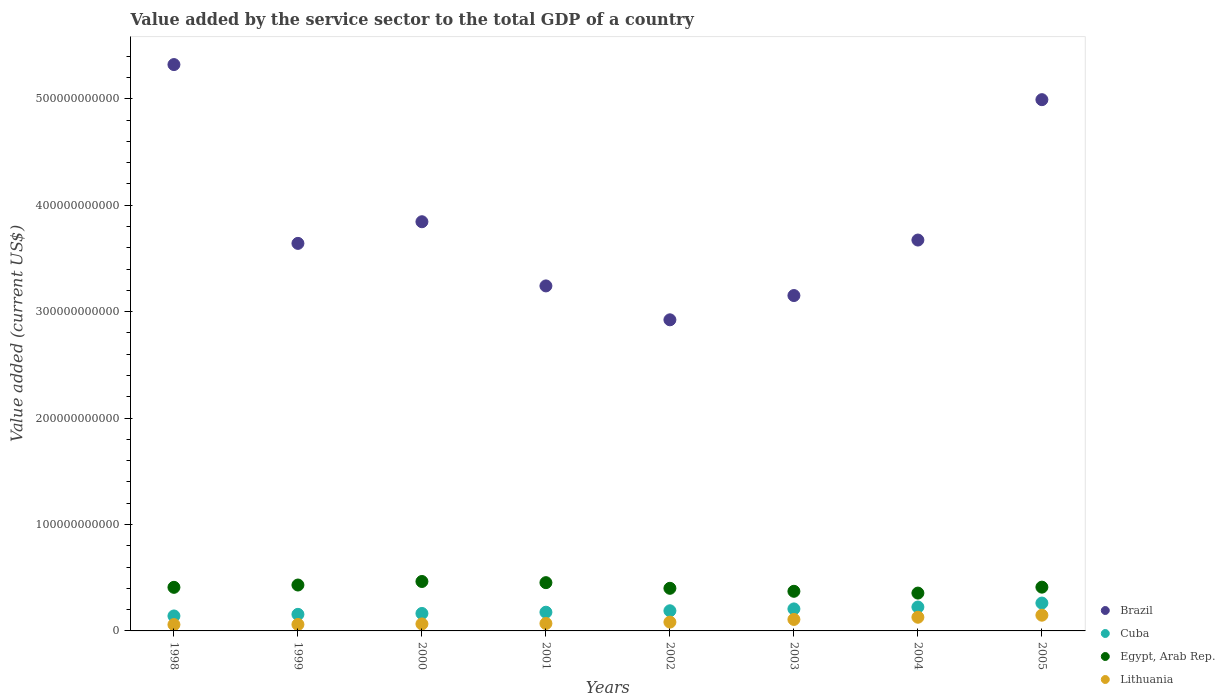Is the number of dotlines equal to the number of legend labels?
Your answer should be compact. Yes. What is the value added by the service sector to the total GDP in Lithuania in 2001?
Make the answer very short. 7.00e+09. Across all years, what is the maximum value added by the service sector to the total GDP in Brazil?
Offer a terse response. 5.32e+11. Across all years, what is the minimum value added by the service sector to the total GDP in Egypt, Arab Rep.?
Make the answer very short. 3.56e+1. In which year was the value added by the service sector to the total GDP in Lithuania maximum?
Your answer should be compact. 2005. In which year was the value added by the service sector to the total GDP in Lithuania minimum?
Keep it short and to the point. 1998. What is the total value added by the service sector to the total GDP in Brazil in the graph?
Keep it short and to the point. 3.08e+12. What is the difference between the value added by the service sector to the total GDP in Lithuania in 2000 and that in 2004?
Provide a short and direct response. -6.28e+09. What is the difference between the value added by the service sector to the total GDP in Egypt, Arab Rep. in 1998 and the value added by the service sector to the total GDP in Cuba in 2004?
Ensure brevity in your answer.  1.85e+1. What is the average value added by the service sector to the total GDP in Cuba per year?
Your answer should be compact. 1.90e+1. In the year 2001, what is the difference between the value added by the service sector to the total GDP in Egypt, Arab Rep. and value added by the service sector to the total GDP in Cuba?
Provide a short and direct response. 2.78e+1. What is the ratio of the value added by the service sector to the total GDP in Lithuania in 1999 to that in 2000?
Make the answer very short. 0.92. What is the difference between the highest and the second highest value added by the service sector to the total GDP in Lithuania?
Make the answer very short. 1.93e+09. What is the difference between the highest and the lowest value added by the service sector to the total GDP in Brazil?
Make the answer very short. 2.40e+11. In how many years, is the value added by the service sector to the total GDP in Lithuania greater than the average value added by the service sector to the total GDP in Lithuania taken over all years?
Make the answer very short. 3. Is the sum of the value added by the service sector to the total GDP in Cuba in 1998 and 1999 greater than the maximum value added by the service sector to the total GDP in Egypt, Arab Rep. across all years?
Your answer should be compact. No. Is the value added by the service sector to the total GDP in Lithuania strictly greater than the value added by the service sector to the total GDP in Egypt, Arab Rep. over the years?
Give a very brief answer. No. What is the difference between two consecutive major ticks on the Y-axis?
Offer a terse response. 1.00e+11. Are the values on the major ticks of Y-axis written in scientific E-notation?
Offer a very short reply. No. Does the graph contain grids?
Ensure brevity in your answer.  No. How many legend labels are there?
Provide a short and direct response. 4. What is the title of the graph?
Provide a short and direct response. Value added by the service sector to the total GDP of a country. Does "Liechtenstein" appear as one of the legend labels in the graph?
Keep it short and to the point. No. What is the label or title of the Y-axis?
Offer a terse response. Value added (current US$). What is the Value added (current US$) of Brazil in 1998?
Your response must be concise. 5.32e+11. What is the Value added (current US$) in Cuba in 1998?
Provide a short and direct response. 1.41e+1. What is the Value added (current US$) in Egypt, Arab Rep. in 1998?
Your answer should be very brief. 4.10e+1. What is the Value added (current US$) in Lithuania in 1998?
Make the answer very short. 5.93e+09. What is the Value added (current US$) of Brazil in 1999?
Make the answer very short. 3.64e+11. What is the Value added (current US$) of Cuba in 1999?
Provide a succinct answer. 1.56e+1. What is the Value added (current US$) of Egypt, Arab Rep. in 1999?
Ensure brevity in your answer.  4.31e+1. What is the Value added (current US$) of Lithuania in 1999?
Provide a short and direct response. 6.06e+09. What is the Value added (current US$) in Brazil in 2000?
Keep it short and to the point. 3.85e+11. What is the Value added (current US$) of Cuba in 2000?
Give a very brief answer. 1.64e+1. What is the Value added (current US$) of Egypt, Arab Rep. in 2000?
Provide a succinct answer. 4.65e+1. What is the Value added (current US$) in Lithuania in 2000?
Ensure brevity in your answer.  6.58e+09. What is the Value added (current US$) in Brazil in 2001?
Offer a terse response. 3.24e+11. What is the Value added (current US$) in Cuba in 2001?
Provide a succinct answer. 1.76e+1. What is the Value added (current US$) in Egypt, Arab Rep. in 2001?
Keep it short and to the point. 4.54e+1. What is the Value added (current US$) of Lithuania in 2001?
Offer a terse response. 7.00e+09. What is the Value added (current US$) in Brazil in 2002?
Give a very brief answer. 2.92e+11. What is the Value added (current US$) in Cuba in 2002?
Provide a succinct answer. 1.89e+1. What is the Value added (current US$) in Egypt, Arab Rep. in 2002?
Provide a succinct answer. 4.01e+1. What is the Value added (current US$) in Lithuania in 2002?
Provide a succinct answer. 8.27e+09. What is the Value added (current US$) in Brazil in 2003?
Keep it short and to the point. 3.15e+11. What is the Value added (current US$) in Cuba in 2003?
Your response must be concise. 2.07e+1. What is the Value added (current US$) of Egypt, Arab Rep. in 2003?
Make the answer very short. 3.72e+1. What is the Value added (current US$) of Lithuania in 2003?
Give a very brief answer. 1.08e+1. What is the Value added (current US$) of Brazil in 2004?
Offer a very short reply. 3.67e+11. What is the Value added (current US$) of Cuba in 2004?
Provide a short and direct response. 2.25e+1. What is the Value added (current US$) in Egypt, Arab Rep. in 2004?
Keep it short and to the point. 3.56e+1. What is the Value added (current US$) of Lithuania in 2004?
Ensure brevity in your answer.  1.29e+1. What is the Value added (current US$) in Brazil in 2005?
Your response must be concise. 4.99e+11. What is the Value added (current US$) of Cuba in 2005?
Your response must be concise. 2.62e+1. What is the Value added (current US$) of Egypt, Arab Rep. in 2005?
Your answer should be compact. 4.11e+1. What is the Value added (current US$) in Lithuania in 2005?
Your answer should be compact. 1.48e+1. Across all years, what is the maximum Value added (current US$) of Brazil?
Your answer should be very brief. 5.32e+11. Across all years, what is the maximum Value added (current US$) in Cuba?
Make the answer very short. 2.62e+1. Across all years, what is the maximum Value added (current US$) in Egypt, Arab Rep.?
Keep it short and to the point. 4.65e+1. Across all years, what is the maximum Value added (current US$) in Lithuania?
Keep it short and to the point. 1.48e+1. Across all years, what is the minimum Value added (current US$) of Brazil?
Offer a very short reply. 2.92e+11. Across all years, what is the minimum Value added (current US$) of Cuba?
Provide a succinct answer. 1.41e+1. Across all years, what is the minimum Value added (current US$) in Egypt, Arab Rep.?
Ensure brevity in your answer.  3.56e+1. Across all years, what is the minimum Value added (current US$) in Lithuania?
Offer a terse response. 5.93e+09. What is the total Value added (current US$) of Brazil in the graph?
Your response must be concise. 3.08e+12. What is the total Value added (current US$) in Cuba in the graph?
Your answer should be very brief. 1.52e+11. What is the total Value added (current US$) of Egypt, Arab Rep. in the graph?
Offer a terse response. 3.30e+11. What is the total Value added (current US$) in Lithuania in the graph?
Provide a succinct answer. 7.23e+1. What is the difference between the Value added (current US$) of Brazil in 1998 and that in 1999?
Offer a terse response. 1.68e+11. What is the difference between the Value added (current US$) in Cuba in 1998 and that in 1999?
Provide a succinct answer. -1.50e+09. What is the difference between the Value added (current US$) of Egypt, Arab Rep. in 1998 and that in 1999?
Ensure brevity in your answer.  -2.18e+09. What is the difference between the Value added (current US$) in Lithuania in 1998 and that in 1999?
Make the answer very short. -1.35e+08. What is the difference between the Value added (current US$) in Brazil in 1998 and that in 2000?
Offer a very short reply. 1.48e+11. What is the difference between the Value added (current US$) in Cuba in 1998 and that in 2000?
Offer a very short reply. -2.34e+09. What is the difference between the Value added (current US$) of Egypt, Arab Rep. in 1998 and that in 2000?
Ensure brevity in your answer.  -5.49e+09. What is the difference between the Value added (current US$) in Lithuania in 1998 and that in 2000?
Make the answer very short. -6.50e+08. What is the difference between the Value added (current US$) in Brazil in 1998 and that in 2001?
Give a very brief answer. 2.08e+11. What is the difference between the Value added (current US$) of Cuba in 1998 and that in 2001?
Ensure brevity in your answer.  -3.52e+09. What is the difference between the Value added (current US$) of Egypt, Arab Rep. in 1998 and that in 2001?
Your response must be concise. -4.40e+09. What is the difference between the Value added (current US$) of Lithuania in 1998 and that in 2001?
Give a very brief answer. -1.07e+09. What is the difference between the Value added (current US$) in Brazil in 1998 and that in 2002?
Offer a terse response. 2.40e+11. What is the difference between the Value added (current US$) in Cuba in 1998 and that in 2002?
Offer a terse response. -4.87e+09. What is the difference between the Value added (current US$) in Egypt, Arab Rep. in 1998 and that in 2002?
Your answer should be compact. 9.12e+08. What is the difference between the Value added (current US$) in Lithuania in 1998 and that in 2002?
Ensure brevity in your answer.  -2.35e+09. What is the difference between the Value added (current US$) in Brazil in 1998 and that in 2003?
Keep it short and to the point. 2.17e+11. What is the difference between the Value added (current US$) in Cuba in 1998 and that in 2003?
Give a very brief answer. -6.61e+09. What is the difference between the Value added (current US$) of Egypt, Arab Rep. in 1998 and that in 2003?
Make the answer very short. 3.73e+09. What is the difference between the Value added (current US$) of Lithuania in 1998 and that in 2003?
Provide a short and direct response. -4.86e+09. What is the difference between the Value added (current US$) of Brazil in 1998 and that in 2004?
Your answer should be compact. 1.65e+11. What is the difference between the Value added (current US$) of Cuba in 1998 and that in 2004?
Provide a short and direct response. -8.40e+09. What is the difference between the Value added (current US$) of Egypt, Arab Rep. in 1998 and that in 2004?
Give a very brief answer. 5.41e+09. What is the difference between the Value added (current US$) of Lithuania in 1998 and that in 2004?
Offer a very short reply. -6.93e+09. What is the difference between the Value added (current US$) of Brazil in 1998 and that in 2005?
Give a very brief answer. 3.30e+1. What is the difference between the Value added (current US$) in Cuba in 1998 and that in 2005?
Your response must be concise. -1.21e+1. What is the difference between the Value added (current US$) of Egypt, Arab Rep. in 1998 and that in 2005?
Your response must be concise. -1.70e+08. What is the difference between the Value added (current US$) in Lithuania in 1998 and that in 2005?
Ensure brevity in your answer.  -8.86e+09. What is the difference between the Value added (current US$) in Brazil in 1999 and that in 2000?
Your answer should be compact. -2.03e+1. What is the difference between the Value added (current US$) of Cuba in 1999 and that in 2000?
Ensure brevity in your answer.  -8.38e+08. What is the difference between the Value added (current US$) in Egypt, Arab Rep. in 1999 and that in 2000?
Provide a short and direct response. -3.31e+09. What is the difference between the Value added (current US$) in Lithuania in 1999 and that in 2000?
Ensure brevity in your answer.  -5.15e+08. What is the difference between the Value added (current US$) in Brazil in 1999 and that in 2001?
Offer a terse response. 4.00e+1. What is the difference between the Value added (current US$) of Cuba in 1999 and that in 2001?
Keep it short and to the point. -2.01e+09. What is the difference between the Value added (current US$) in Egypt, Arab Rep. in 1999 and that in 2001?
Give a very brief answer. -2.22e+09. What is the difference between the Value added (current US$) of Lithuania in 1999 and that in 2001?
Provide a succinct answer. -9.35e+08. What is the difference between the Value added (current US$) in Brazil in 1999 and that in 2002?
Give a very brief answer. 7.18e+1. What is the difference between the Value added (current US$) in Cuba in 1999 and that in 2002?
Provide a succinct answer. -3.36e+09. What is the difference between the Value added (current US$) in Egypt, Arab Rep. in 1999 and that in 2002?
Your response must be concise. 3.09e+09. What is the difference between the Value added (current US$) of Lithuania in 1999 and that in 2002?
Provide a succinct answer. -2.21e+09. What is the difference between the Value added (current US$) of Brazil in 1999 and that in 2003?
Offer a terse response. 4.90e+1. What is the difference between the Value added (current US$) in Cuba in 1999 and that in 2003?
Offer a terse response. -5.11e+09. What is the difference between the Value added (current US$) in Egypt, Arab Rep. in 1999 and that in 2003?
Provide a succinct answer. 5.90e+09. What is the difference between the Value added (current US$) in Lithuania in 1999 and that in 2003?
Your response must be concise. -4.73e+09. What is the difference between the Value added (current US$) of Brazil in 1999 and that in 2004?
Make the answer very short. -3.14e+09. What is the difference between the Value added (current US$) of Cuba in 1999 and that in 2004?
Keep it short and to the point. -6.90e+09. What is the difference between the Value added (current US$) in Egypt, Arab Rep. in 1999 and that in 2004?
Keep it short and to the point. 7.59e+09. What is the difference between the Value added (current US$) in Lithuania in 1999 and that in 2004?
Offer a very short reply. -6.79e+09. What is the difference between the Value added (current US$) of Brazil in 1999 and that in 2005?
Offer a terse response. -1.35e+11. What is the difference between the Value added (current US$) of Cuba in 1999 and that in 2005?
Give a very brief answer. -1.06e+1. What is the difference between the Value added (current US$) of Egypt, Arab Rep. in 1999 and that in 2005?
Provide a succinct answer. 2.01e+09. What is the difference between the Value added (current US$) of Lithuania in 1999 and that in 2005?
Give a very brief answer. -8.72e+09. What is the difference between the Value added (current US$) in Brazil in 2000 and that in 2001?
Offer a very short reply. 6.03e+1. What is the difference between the Value added (current US$) of Cuba in 2000 and that in 2001?
Offer a terse response. -1.17e+09. What is the difference between the Value added (current US$) of Egypt, Arab Rep. in 2000 and that in 2001?
Provide a short and direct response. 1.09e+09. What is the difference between the Value added (current US$) in Lithuania in 2000 and that in 2001?
Ensure brevity in your answer.  -4.20e+08. What is the difference between the Value added (current US$) in Brazil in 2000 and that in 2002?
Offer a very short reply. 9.22e+1. What is the difference between the Value added (current US$) of Cuba in 2000 and that in 2002?
Provide a short and direct response. -2.53e+09. What is the difference between the Value added (current US$) in Egypt, Arab Rep. in 2000 and that in 2002?
Your answer should be very brief. 6.40e+09. What is the difference between the Value added (current US$) of Lithuania in 2000 and that in 2002?
Ensure brevity in your answer.  -1.70e+09. What is the difference between the Value added (current US$) of Brazil in 2000 and that in 2003?
Provide a short and direct response. 6.94e+1. What is the difference between the Value added (current US$) of Cuba in 2000 and that in 2003?
Make the answer very short. -4.27e+09. What is the difference between the Value added (current US$) in Egypt, Arab Rep. in 2000 and that in 2003?
Give a very brief answer. 9.21e+09. What is the difference between the Value added (current US$) in Lithuania in 2000 and that in 2003?
Offer a very short reply. -4.21e+09. What is the difference between the Value added (current US$) in Brazil in 2000 and that in 2004?
Provide a short and direct response. 1.72e+1. What is the difference between the Value added (current US$) in Cuba in 2000 and that in 2004?
Ensure brevity in your answer.  -6.06e+09. What is the difference between the Value added (current US$) of Egypt, Arab Rep. in 2000 and that in 2004?
Offer a very short reply. 1.09e+1. What is the difference between the Value added (current US$) of Lithuania in 2000 and that in 2004?
Your response must be concise. -6.28e+09. What is the difference between the Value added (current US$) of Brazil in 2000 and that in 2005?
Offer a terse response. -1.15e+11. What is the difference between the Value added (current US$) in Cuba in 2000 and that in 2005?
Keep it short and to the point. -9.77e+09. What is the difference between the Value added (current US$) of Egypt, Arab Rep. in 2000 and that in 2005?
Ensure brevity in your answer.  5.32e+09. What is the difference between the Value added (current US$) in Lithuania in 2000 and that in 2005?
Ensure brevity in your answer.  -8.21e+09. What is the difference between the Value added (current US$) in Brazil in 2001 and that in 2002?
Your response must be concise. 3.18e+1. What is the difference between the Value added (current US$) in Cuba in 2001 and that in 2002?
Provide a short and direct response. -1.35e+09. What is the difference between the Value added (current US$) of Egypt, Arab Rep. in 2001 and that in 2002?
Your answer should be very brief. 5.31e+09. What is the difference between the Value added (current US$) of Lithuania in 2001 and that in 2002?
Give a very brief answer. -1.28e+09. What is the difference between the Value added (current US$) of Brazil in 2001 and that in 2003?
Give a very brief answer. 9.05e+09. What is the difference between the Value added (current US$) in Cuba in 2001 and that in 2003?
Ensure brevity in your answer.  -3.10e+09. What is the difference between the Value added (current US$) in Egypt, Arab Rep. in 2001 and that in 2003?
Your response must be concise. 8.12e+09. What is the difference between the Value added (current US$) of Lithuania in 2001 and that in 2003?
Keep it short and to the point. -3.79e+09. What is the difference between the Value added (current US$) of Brazil in 2001 and that in 2004?
Offer a terse response. -4.31e+1. What is the difference between the Value added (current US$) of Cuba in 2001 and that in 2004?
Give a very brief answer. -4.88e+09. What is the difference between the Value added (current US$) of Egypt, Arab Rep. in 2001 and that in 2004?
Your answer should be compact. 9.81e+09. What is the difference between the Value added (current US$) in Lithuania in 2001 and that in 2004?
Provide a succinct answer. -5.86e+09. What is the difference between the Value added (current US$) of Brazil in 2001 and that in 2005?
Provide a succinct answer. -1.75e+11. What is the difference between the Value added (current US$) in Cuba in 2001 and that in 2005?
Make the answer very short. -8.60e+09. What is the difference between the Value added (current US$) of Egypt, Arab Rep. in 2001 and that in 2005?
Your answer should be very brief. 4.23e+09. What is the difference between the Value added (current US$) in Lithuania in 2001 and that in 2005?
Your response must be concise. -7.79e+09. What is the difference between the Value added (current US$) in Brazil in 2002 and that in 2003?
Ensure brevity in your answer.  -2.28e+1. What is the difference between the Value added (current US$) in Cuba in 2002 and that in 2003?
Offer a terse response. -1.74e+09. What is the difference between the Value added (current US$) of Egypt, Arab Rep. in 2002 and that in 2003?
Provide a short and direct response. 2.81e+09. What is the difference between the Value added (current US$) in Lithuania in 2002 and that in 2003?
Provide a succinct answer. -2.51e+09. What is the difference between the Value added (current US$) of Brazil in 2002 and that in 2004?
Your answer should be compact. -7.50e+1. What is the difference between the Value added (current US$) in Cuba in 2002 and that in 2004?
Provide a short and direct response. -3.53e+09. What is the difference between the Value added (current US$) in Egypt, Arab Rep. in 2002 and that in 2004?
Your answer should be compact. 4.50e+09. What is the difference between the Value added (current US$) in Lithuania in 2002 and that in 2004?
Offer a very short reply. -4.58e+09. What is the difference between the Value added (current US$) in Brazil in 2002 and that in 2005?
Keep it short and to the point. -2.07e+11. What is the difference between the Value added (current US$) in Cuba in 2002 and that in 2005?
Provide a succinct answer. -7.25e+09. What is the difference between the Value added (current US$) in Egypt, Arab Rep. in 2002 and that in 2005?
Give a very brief answer. -1.08e+09. What is the difference between the Value added (current US$) of Lithuania in 2002 and that in 2005?
Provide a short and direct response. -6.51e+09. What is the difference between the Value added (current US$) in Brazil in 2003 and that in 2004?
Your response must be concise. -5.22e+1. What is the difference between the Value added (current US$) of Cuba in 2003 and that in 2004?
Your answer should be compact. -1.79e+09. What is the difference between the Value added (current US$) in Egypt, Arab Rep. in 2003 and that in 2004?
Your answer should be compact. 1.68e+09. What is the difference between the Value added (current US$) of Lithuania in 2003 and that in 2004?
Offer a terse response. -2.07e+09. What is the difference between the Value added (current US$) in Brazil in 2003 and that in 2005?
Ensure brevity in your answer.  -1.84e+11. What is the difference between the Value added (current US$) of Cuba in 2003 and that in 2005?
Your answer should be compact. -5.51e+09. What is the difference between the Value added (current US$) of Egypt, Arab Rep. in 2003 and that in 2005?
Provide a short and direct response. -3.90e+09. What is the difference between the Value added (current US$) in Lithuania in 2003 and that in 2005?
Keep it short and to the point. -4.00e+09. What is the difference between the Value added (current US$) in Brazil in 2004 and that in 2005?
Ensure brevity in your answer.  -1.32e+11. What is the difference between the Value added (current US$) in Cuba in 2004 and that in 2005?
Provide a succinct answer. -3.72e+09. What is the difference between the Value added (current US$) in Egypt, Arab Rep. in 2004 and that in 2005?
Provide a succinct answer. -5.58e+09. What is the difference between the Value added (current US$) of Lithuania in 2004 and that in 2005?
Your answer should be very brief. -1.93e+09. What is the difference between the Value added (current US$) of Brazil in 1998 and the Value added (current US$) of Cuba in 1999?
Offer a terse response. 5.17e+11. What is the difference between the Value added (current US$) in Brazil in 1998 and the Value added (current US$) in Egypt, Arab Rep. in 1999?
Offer a terse response. 4.89e+11. What is the difference between the Value added (current US$) of Brazil in 1998 and the Value added (current US$) of Lithuania in 1999?
Provide a succinct answer. 5.26e+11. What is the difference between the Value added (current US$) in Cuba in 1998 and the Value added (current US$) in Egypt, Arab Rep. in 1999?
Your response must be concise. -2.91e+1. What is the difference between the Value added (current US$) of Cuba in 1998 and the Value added (current US$) of Lithuania in 1999?
Your response must be concise. 8.00e+09. What is the difference between the Value added (current US$) in Egypt, Arab Rep. in 1998 and the Value added (current US$) in Lithuania in 1999?
Your response must be concise. 3.49e+1. What is the difference between the Value added (current US$) in Brazil in 1998 and the Value added (current US$) in Cuba in 2000?
Your answer should be compact. 5.16e+11. What is the difference between the Value added (current US$) in Brazil in 1998 and the Value added (current US$) in Egypt, Arab Rep. in 2000?
Keep it short and to the point. 4.86e+11. What is the difference between the Value added (current US$) of Brazil in 1998 and the Value added (current US$) of Lithuania in 2000?
Give a very brief answer. 5.26e+11. What is the difference between the Value added (current US$) of Cuba in 1998 and the Value added (current US$) of Egypt, Arab Rep. in 2000?
Your response must be concise. -3.24e+1. What is the difference between the Value added (current US$) of Cuba in 1998 and the Value added (current US$) of Lithuania in 2000?
Your response must be concise. 7.49e+09. What is the difference between the Value added (current US$) of Egypt, Arab Rep. in 1998 and the Value added (current US$) of Lithuania in 2000?
Give a very brief answer. 3.44e+1. What is the difference between the Value added (current US$) of Brazil in 1998 and the Value added (current US$) of Cuba in 2001?
Your answer should be very brief. 5.15e+11. What is the difference between the Value added (current US$) of Brazil in 1998 and the Value added (current US$) of Egypt, Arab Rep. in 2001?
Offer a terse response. 4.87e+11. What is the difference between the Value added (current US$) in Brazil in 1998 and the Value added (current US$) in Lithuania in 2001?
Offer a very short reply. 5.25e+11. What is the difference between the Value added (current US$) of Cuba in 1998 and the Value added (current US$) of Egypt, Arab Rep. in 2001?
Offer a terse response. -3.13e+1. What is the difference between the Value added (current US$) of Cuba in 1998 and the Value added (current US$) of Lithuania in 2001?
Provide a short and direct response. 7.07e+09. What is the difference between the Value added (current US$) of Egypt, Arab Rep. in 1998 and the Value added (current US$) of Lithuania in 2001?
Make the answer very short. 3.40e+1. What is the difference between the Value added (current US$) of Brazil in 1998 and the Value added (current US$) of Cuba in 2002?
Keep it short and to the point. 5.13e+11. What is the difference between the Value added (current US$) in Brazil in 1998 and the Value added (current US$) in Egypt, Arab Rep. in 2002?
Keep it short and to the point. 4.92e+11. What is the difference between the Value added (current US$) of Brazil in 1998 and the Value added (current US$) of Lithuania in 2002?
Make the answer very short. 5.24e+11. What is the difference between the Value added (current US$) in Cuba in 1998 and the Value added (current US$) in Egypt, Arab Rep. in 2002?
Keep it short and to the point. -2.60e+1. What is the difference between the Value added (current US$) in Cuba in 1998 and the Value added (current US$) in Lithuania in 2002?
Your answer should be very brief. 5.79e+09. What is the difference between the Value added (current US$) in Egypt, Arab Rep. in 1998 and the Value added (current US$) in Lithuania in 2002?
Offer a very short reply. 3.27e+1. What is the difference between the Value added (current US$) of Brazil in 1998 and the Value added (current US$) of Cuba in 2003?
Provide a short and direct response. 5.12e+11. What is the difference between the Value added (current US$) of Brazil in 1998 and the Value added (current US$) of Egypt, Arab Rep. in 2003?
Make the answer very short. 4.95e+11. What is the difference between the Value added (current US$) in Brazil in 1998 and the Value added (current US$) in Lithuania in 2003?
Keep it short and to the point. 5.21e+11. What is the difference between the Value added (current US$) of Cuba in 1998 and the Value added (current US$) of Egypt, Arab Rep. in 2003?
Provide a succinct answer. -2.32e+1. What is the difference between the Value added (current US$) in Cuba in 1998 and the Value added (current US$) in Lithuania in 2003?
Offer a very short reply. 3.28e+09. What is the difference between the Value added (current US$) of Egypt, Arab Rep. in 1998 and the Value added (current US$) of Lithuania in 2003?
Keep it short and to the point. 3.02e+1. What is the difference between the Value added (current US$) in Brazil in 1998 and the Value added (current US$) in Cuba in 2004?
Offer a very short reply. 5.10e+11. What is the difference between the Value added (current US$) of Brazil in 1998 and the Value added (current US$) of Egypt, Arab Rep. in 2004?
Your answer should be compact. 4.97e+11. What is the difference between the Value added (current US$) of Brazil in 1998 and the Value added (current US$) of Lithuania in 2004?
Offer a very short reply. 5.19e+11. What is the difference between the Value added (current US$) of Cuba in 1998 and the Value added (current US$) of Egypt, Arab Rep. in 2004?
Make the answer very short. -2.15e+1. What is the difference between the Value added (current US$) of Cuba in 1998 and the Value added (current US$) of Lithuania in 2004?
Your response must be concise. 1.21e+09. What is the difference between the Value added (current US$) of Egypt, Arab Rep. in 1998 and the Value added (current US$) of Lithuania in 2004?
Make the answer very short. 2.81e+1. What is the difference between the Value added (current US$) in Brazil in 1998 and the Value added (current US$) in Cuba in 2005?
Make the answer very short. 5.06e+11. What is the difference between the Value added (current US$) in Brazil in 1998 and the Value added (current US$) in Egypt, Arab Rep. in 2005?
Make the answer very short. 4.91e+11. What is the difference between the Value added (current US$) of Brazil in 1998 and the Value added (current US$) of Lithuania in 2005?
Offer a very short reply. 5.17e+11. What is the difference between the Value added (current US$) in Cuba in 1998 and the Value added (current US$) in Egypt, Arab Rep. in 2005?
Make the answer very short. -2.71e+1. What is the difference between the Value added (current US$) of Cuba in 1998 and the Value added (current US$) of Lithuania in 2005?
Offer a terse response. -7.17e+08. What is the difference between the Value added (current US$) of Egypt, Arab Rep. in 1998 and the Value added (current US$) of Lithuania in 2005?
Provide a short and direct response. 2.62e+1. What is the difference between the Value added (current US$) of Brazil in 1999 and the Value added (current US$) of Cuba in 2000?
Provide a short and direct response. 3.48e+11. What is the difference between the Value added (current US$) of Brazil in 1999 and the Value added (current US$) of Egypt, Arab Rep. in 2000?
Your answer should be very brief. 3.18e+11. What is the difference between the Value added (current US$) in Brazil in 1999 and the Value added (current US$) in Lithuania in 2000?
Provide a succinct answer. 3.58e+11. What is the difference between the Value added (current US$) of Cuba in 1999 and the Value added (current US$) of Egypt, Arab Rep. in 2000?
Ensure brevity in your answer.  -3.09e+1. What is the difference between the Value added (current US$) of Cuba in 1999 and the Value added (current US$) of Lithuania in 2000?
Provide a short and direct response. 8.99e+09. What is the difference between the Value added (current US$) in Egypt, Arab Rep. in 1999 and the Value added (current US$) in Lithuania in 2000?
Keep it short and to the point. 3.66e+1. What is the difference between the Value added (current US$) of Brazil in 1999 and the Value added (current US$) of Cuba in 2001?
Your response must be concise. 3.47e+11. What is the difference between the Value added (current US$) in Brazil in 1999 and the Value added (current US$) in Egypt, Arab Rep. in 2001?
Your answer should be very brief. 3.19e+11. What is the difference between the Value added (current US$) in Brazil in 1999 and the Value added (current US$) in Lithuania in 2001?
Your answer should be compact. 3.57e+11. What is the difference between the Value added (current US$) of Cuba in 1999 and the Value added (current US$) of Egypt, Arab Rep. in 2001?
Your answer should be compact. -2.98e+1. What is the difference between the Value added (current US$) in Cuba in 1999 and the Value added (current US$) in Lithuania in 2001?
Ensure brevity in your answer.  8.57e+09. What is the difference between the Value added (current US$) in Egypt, Arab Rep. in 1999 and the Value added (current US$) in Lithuania in 2001?
Your answer should be compact. 3.61e+1. What is the difference between the Value added (current US$) in Brazil in 1999 and the Value added (current US$) in Cuba in 2002?
Provide a succinct answer. 3.45e+11. What is the difference between the Value added (current US$) in Brazil in 1999 and the Value added (current US$) in Egypt, Arab Rep. in 2002?
Your answer should be compact. 3.24e+11. What is the difference between the Value added (current US$) of Brazil in 1999 and the Value added (current US$) of Lithuania in 2002?
Offer a very short reply. 3.56e+11. What is the difference between the Value added (current US$) of Cuba in 1999 and the Value added (current US$) of Egypt, Arab Rep. in 2002?
Your answer should be very brief. -2.45e+1. What is the difference between the Value added (current US$) in Cuba in 1999 and the Value added (current US$) in Lithuania in 2002?
Give a very brief answer. 7.30e+09. What is the difference between the Value added (current US$) in Egypt, Arab Rep. in 1999 and the Value added (current US$) in Lithuania in 2002?
Your answer should be very brief. 3.49e+1. What is the difference between the Value added (current US$) in Brazil in 1999 and the Value added (current US$) in Cuba in 2003?
Your response must be concise. 3.44e+11. What is the difference between the Value added (current US$) in Brazil in 1999 and the Value added (current US$) in Egypt, Arab Rep. in 2003?
Provide a short and direct response. 3.27e+11. What is the difference between the Value added (current US$) in Brazil in 1999 and the Value added (current US$) in Lithuania in 2003?
Provide a short and direct response. 3.53e+11. What is the difference between the Value added (current US$) in Cuba in 1999 and the Value added (current US$) in Egypt, Arab Rep. in 2003?
Offer a terse response. -2.17e+1. What is the difference between the Value added (current US$) in Cuba in 1999 and the Value added (current US$) in Lithuania in 2003?
Give a very brief answer. 4.78e+09. What is the difference between the Value added (current US$) in Egypt, Arab Rep. in 1999 and the Value added (current US$) in Lithuania in 2003?
Offer a very short reply. 3.24e+1. What is the difference between the Value added (current US$) in Brazil in 1999 and the Value added (current US$) in Cuba in 2004?
Provide a succinct answer. 3.42e+11. What is the difference between the Value added (current US$) in Brazil in 1999 and the Value added (current US$) in Egypt, Arab Rep. in 2004?
Ensure brevity in your answer.  3.29e+11. What is the difference between the Value added (current US$) of Brazil in 1999 and the Value added (current US$) of Lithuania in 2004?
Offer a very short reply. 3.51e+11. What is the difference between the Value added (current US$) in Cuba in 1999 and the Value added (current US$) in Egypt, Arab Rep. in 2004?
Provide a succinct answer. -2.00e+1. What is the difference between the Value added (current US$) in Cuba in 1999 and the Value added (current US$) in Lithuania in 2004?
Ensure brevity in your answer.  2.72e+09. What is the difference between the Value added (current US$) in Egypt, Arab Rep. in 1999 and the Value added (current US$) in Lithuania in 2004?
Provide a succinct answer. 3.03e+1. What is the difference between the Value added (current US$) in Brazil in 1999 and the Value added (current US$) in Cuba in 2005?
Offer a terse response. 3.38e+11. What is the difference between the Value added (current US$) in Brazil in 1999 and the Value added (current US$) in Egypt, Arab Rep. in 2005?
Offer a very short reply. 3.23e+11. What is the difference between the Value added (current US$) in Brazil in 1999 and the Value added (current US$) in Lithuania in 2005?
Provide a short and direct response. 3.49e+11. What is the difference between the Value added (current US$) of Cuba in 1999 and the Value added (current US$) of Egypt, Arab Rep. in 2005?
Offer a terse response. -2.56e+1. What is the difference between the Value added (current US$) in Cuba in 1999 and the Value added (current US$) in Lithuania in 2005?
Your answer should be compact. 7.87e+08. What is the difference between the Value added (current US$) of Egypt, Arab Rep. in 1999 and the Value added (current US$) of Lithuania in 2005?
Your answer should be compact. 2.84e+1. What is the difference between the Value added (current US$) in Brazil in 2000 and the Value added (current US$) in Cuba in 2001?
Keep it short and to the point. 3.67e+11. What is the difference between the Value added (current US$) in Brazil in 2000 and the Value added (current US$) in Egypt, Arab Rep. in 2001?
Give a very brief answer. 3.39e+11. What is the difference between the Value added (current US$) of Brazil in 2000 and the Value added (current US$) of Lithuania in 2001?
Make the answer very short. 3.78e+11. What is the difference between the Value added (current US$) of Cuba in 2000 and the Value added (current US$) of Egypt, Arab Rep. in 2001?
Give a very brief answer. -2.90e+1. What is the difference between the Value added (current US$) of Cuba in 2000 and the Value added (current US$) of Lithuania in 2001?
Offer a terse response. 9.41e+09. What is the difference between the Value added (current US$) of Egypt, Arab Rep. in 2000 and the Value added (current US$) of Lithuania in 2001?
Keep it short and to the point. 3.95e+1. What is the difference between the Value added (current US$) in Brazil in 2000 and the Value added (current US$) in Cuba in 2002?
Provide a short and direct response. 3.66e+11. What is the difference between the Value added (current US$) of Brazil in 2000 and the Value added (current US$) of Egypt, Arab Rep. in 2002?
Provide a short and direct response. 3.44e+11. What is the difference between the Value added (current US$) in Brazil in 2000 and the Value added (current US$) in Lithuania in 2002?
Your answer should be compact. 3.76e+11. What is the difference between the Value added (current US$) of Cuba in 2000 and the Value added (current US$) of Egypt, Arab Rep. in 2002?
Offer a very short reply. -2.36e+1. What is the difference between the Value added (current US$) of Cuba in 2000 and the Value added (current US$) of Lithuania in 2002?
Offer a terse response. 8.13e+09. What is the difference between the Value added (current US$) of Egypt, Arab Rep. in 2000 and the Value added (current US$) of Lithuania in 2002?
Provide a succinct answer. 3.82e+1. What is the difference between the Value added (current US$) of Brazil in 2000 and the Value added (current US$) of Cuba in 2003?
Offer a terse response. 3.64e+11. What is the difference between the Value added (current US$) of Brazil in 2000 and the Value added (current US$) of Egypt, Arab Rep. in 2003?
Provide a succinct answer. 3.47e+11. What is the difference between the Value added (current US$) of Brazil in 2000 and the Value added (current US$) of Lithuania in 2003?
Your answer should be compact. 3.74e+11. What is the difference between the Value added (current US$) in Cuba in 2000 and the Value added (current US$) in Egypt, Arab Rep. in 2003?
Make the answer very short. -2.08e+1. What is the difference between the Value added (current US$) of Cuba in 2000 and the Value added (current US$) of Lithuania in 2003?
Ensure brevity in your answer.  5.62e+09. What is the difference between the Value added (current US$) of Egypt, Arab Rep. in 2000 and the Value added (current US$) of Lithuania in 2003?
Provide a succinct answer. 3.57e+1. What is the difference between the Value added (current US$) in Brazil in 2000 and the Value added (current US$) in Cuba in 2004?
Make the answer very short. 3.62e+11. What is the difference between the Value added (current US$) of Brazil in 2000 and the Value added (current US$) of Egypt, Arab Rep. in 2004?
Give a very brief answer. 3.49e+11. What is the difference between the Value added (current US$) of Brazil in 2000 and the Value added (current US$) of Lithuania in 2004?
Ensure brevity in your answer.  3.72e+11. What is the difference between the Value added (current US$) in Cuba in 2000 and the Value added (current US$) in Egypt, Arab Rep. in 2004?
Provide a short and direct response. -1.91e+1. What is the difference between the Value added (current US$) of Cuba in 2000 and the Value added (current US$) of Lithuania in 2004?
Ensure brevity in your answer.  3.55e+09. What is the difference between the Value added (current US$) in Egypt, Arab Rep. in 2000 and the Value added (current US$) in Lithuania in 2004?
Offer a very short reply. 3.36e+1. What is the difference between the Value added (current US$) in Brazil in 2000 and the Value added (current US$) in Cuba in 2005?
Your answer should be very brief. 3.58e+11. What is the difference between the Value added (current US$) in Brazil in 2000 and the Value added (current US$) in Egypt, Arab Rep. in 2005?
Offer a terse response. 3.43e+11. What is the difference between the Value added (current US$) in Brazil in 2000 and the Value added (current US$) in Lithuania in 2005?
Give a very brief answer. 3.70e+11. What is the difference between the Value added (current US$) of Cuba in 2000 and the Value added (current US$) of Egypt, Arab Rep. in 2005?
Provide a short and direct response. -2.47e+1. What is the difference between the Value added (current US$) of Cuba in 2000 and the Value added (current US$) of Lithuania in 2005?
Your answer should be compact. 1.62e+09. What is the difference between the Value added (current US$) in Egypt, Arab Rep. in 2000 and the Value added (current US$) in Lithuania in 2005?
Ensure brevity in your answer.  3.17e+1. What is the difference between the Value added (current US$) in Brazil in 2001 and the Value added (current US$) in Cuba in 2002?
Offer a very short reply. 3.05e+11. What is the difference between the Value added (current US$) of Brazil in 2001 and the Value added (current US$) of Egypt, Arab Rep. in 2002?
Provide a short and direct response. 2.84e+11. What is the difference between the Value added (current US$) of Brazil in 2001 and the Value added (current US$) of Lithuania in 2002?
Offer a terse response. 3.16e+11. What is the difference between the Value added (current US$) in Cuba in 2001 and the Value added (current US$) in Egypt, Arab Rep. in 2002?
Your answer should be very brief. -2.25e+1. What is the difference between the Value added (current US$) in Cuba in 2001 and the Value added (current US$) in Lithuania in 2002?
Keep it short and to the point. 9.31e+09. What is the difference between the Value added (current US$) of Egypt, Arab Rep. in 2001 and the Value added (current US$) of Lithuania in 2002?
Your answer should be compact. 3.71e+1. What is the difference between the Value added (current US$) in Brazil in 2001 and the Value added (current US$) in Cuba in 2003?
Your response must be concise. 3.04e+11. What is the difference between the Value added (current US$) in Brazil in 2001 and the Value added (current US$) in Egypt, Arab Rep. in 2003?
Offer a very short reply. 2.87e+11. What is the difference between the Value added (current US$) of Brazil in 2001 and the Value added (current US$) of Lithuania in 2003?
Your answer should be very brief. 3.13e+11. What is the difference between the Value added (current US$) in Cuba in 2001 and the Value added (current US$) in Egypt, Arab Rep. in 2003?
Offer a terse response. -1.97e+1. What is the difference between the Value added (current US$) in Cuba in 2001 and the Value added (current US$) in Lithuania in 2003?
Your response must be concise. 6.79e+09. What is the difference between the Value added (current US$) in Egypt, Arab Rep. in 2001 and the Value added (current US$) in Lithuania in 2003?
Offer a terse response. 3.46e+1. What is the difference between the Value added (current US$) of Brazil in 2001 and the Value added (current US$) of Cuba in 2004?
Ensure brevity in your answer.  3.02e+11. What is the difference between the Value added (current US$) in Brazil in 2001 and the Value added (current US$) in Egypt, Arab Rep. in 2004?
Give a very brief answer. 2.89e+11. What is the difference between the Value added (current US$) of Brazil in 2001 and the Value added (current US$) of Lithuania in 2004?
Ensure brevity in your answer.  3.11e+11. What is the difference between the Value added (current US$) of Cuba in 2001 and the Value added (current US$) of Egypt, Arab Rep. in 2004?
Give a very brief answer. -1.80e+1. What is the difference between the Value added (current US$) in Cuba in 2001 and the Value added (current US$) in Lithuania in 2004?
Your response must be concise. 4.73e+09. What is the difference between the Value added (current US$) in Egypt, Arab Rep. in 2001 and the Value added (current US$) in Lithuania in 2004?
Keep it short and to the point. 3.25e+1. What is the difference between the Value added (current US$) in Brazil in 2001 and the Value added (current US$) in Cuba in 2005?
Provide a short and direct response. 2.98e+11. What is the difference between the Value added (current US$) in Brazil in 2001 and the Value added (current US$) in Egypt, Arab Rep. in 2005?
Offer a very short reply. 2.83e+11. What is the difference between the Value added (current US$) in Brazil in 2001 and the Value added (current US$) in Lithuania in 2005?
Make the answer very short. 3.09e+11. What is the difference between the Value added (current US$) of Cuba in 2001 and the Value added (current US$) of Egypt, Arab Rep. in 2005?
Your response must be concise. -2.36e+1. What is the difference between the Value added (current US$) in Cuba in 2001 and the Value added (current US$) in Lithuania in 2005?
Make the answer very short. 2.80e+09. What is the difference between the Value added (current US$) in Egypt, Arab Rep. in 2001 and the Value added (current US$) in Lithuania in 2005?
Keep it short and to the point. 3.06e+1. What is the difference between the Value added (current US$) in Brazil in 2002 and the Value added (current US$) in Cuba in 2003?
Your response must be concise. 2.72e+11. What is the difference between the Value added (current US$) in Brazil in 2002 and the Value added (current US$) in Egypt, Arab Rep. in 2003?
Give a very brief answer. 2.55e+11. What is the difference between the Value added (current US$) in Brazil in 2002 and the Value added (current US$) in Lithuania in 2003?
Give a very brief answer. 2.82e+11. What is the difference between the Value added (current US$) of Cuba in 2002 and the Value added (current US$) of Egypt, Arab Rep. in 2003?
Your response must be concise. -1.83e+1. What is the difference between the Value added (current US$) in Cuba in 2002 and the Value added (current US$) in Lithuania in 2003?
Offer a terse response. 8.15e+09. What is the difference between the Value added (current US$) in Egypt, Arab Rep. in 2002 and the Value added (current US$) in Lithuania in 2003?
Your answer should be very brief. 2.93e+1. What is the difference between the Value added (current US$) of Brazil in 2002 and the Value added (current US$) of Cuba in 2004?
Give a very brief answer. 2.70e+11. What is the difference between the Value added (current US$) in Brazil in 2002 and the Value added (current US$) in Egypt, Arab Rep. in 2004?
Provide a short and direct response. 2.57e+11. What is the difference between the Value added (current US$) in Brazil in 2002 and the Value added (current US$) in Lithuania in 2004?
Provide a succinct answer. 2.80e+11. What is the difference between the Value added (current US$) in Cuba in 2002 and the Value added (current US$) in Egypt, Arab Rep. in 2004?
Provide a succinct answer. -1.66e+1. What is the difference between the Value added (current US$) in Cuba in 2002 and the Value added (current US$) in Lithuania in 2004?
Your answer should be very brief. 6.08e+09. What is the difference between the Value added (current US$) in Egypt, Arab Rep. in 2002 and the Value added (current US$) in Lithuania in 2004?
Offer a very short reply. 2.72e+1. What is the difference between the Value added (current US$) of Brazil in 2002 and the Value added (current US$) of Cuba in 2005?
Give a very brief answer. 2.66e+11. What is the difference between the Value added (current US$) of Brazil in 2002 and the Value added (current US$) of Egypt, Arab Rep. in 2005?
Your answer should be compact. 2.51e+11. What is the difference between the Value added (current US$) of Brazil in 2002 and the Value added (current US$) of Lithuania in 2005?
Make the answer very short. 2.78e+11. What is the difference between the Value added (current US$) in Cuba in 2002 and the Value added (current US$) in Egypt, Arab Rep. in 2005?
Offer a very short reply. -2.22e+1. What is the difference between the Value added (current US$) of Cuba in 2002 and the Value added (current US$) of Lithuania in 2005?
Provide a short and direct response. 4.15e+09. What is the difference between the Value added (current US$) in Egypt, Arab Rep. in 2002 and the Value added (current US$) in Lithuania in 2005?
Your response must be concise. 2.53e+1. What is the difference between the Value added (current US$) in Brazil in 2003 and the Value added (current US$) in Cuba in 2004?
Give a very brief answer. 2.93e+11. What is the difference between the Value added (current US$) of Brazil in 2003 and the Value added (current US$) of Egypt, Arab Rep. in 2004?
Your answer should be very brief. 2.80e+11. What is the difference between the Value added (current US$) of Brazil in 2003 and the Value added (current US$) of Lithuania in 2004?
Make the answer very short. 3.02e+11. What is the difference between the Value added (current US$) in Cuba in 2003 and the Value added (current US$) in Egypt, Arab Rep. in 2004?
Keep it short and to the point. -1.49e+1. What is the difference between the Value added (current US$) in Cuba in 2003 and the Value added (current US$) in Lithuania in 2004?
Provide a succinct answer. 7.82e+09. What is the difference between the Value added (current US$) of Egypt, Arab Rep. in 2003 and the Value added (current US$) of Lithuania in 2004?
Keep it short and to the point. 2.44e+1. What is the difference between the Value added (current US$) of Brazil in 2003 and the Value added (current US$) of Cuba in 2005?
Offer a very short reply. 2.89e+11. What is the difference between the Value added (current US$) of Brazil in 2003 and the Value added (current US$) of Egypt, Arab Rep. in 2005?
Your response must be concise. 2.74e+11. What is the difference between the Value added (current US$) of Brazil in 2003 and the Value added (current US$) of Lithuania in 2005?
Your response must be concise. 3.00e+11. What is the difference between the Value added (current US$) of Cuba in 2003 and the Value added (current US$) of Egypt, Arab Rep. in 2005?
Keep it short and to the point. -2.05e+1. What is the difference between the Value added (current US$) in Cuba in 2003 and the Value added (current US$) in Lithuania in 2005?
Give a very brief answer. 5.89e+09. What is the difference between the Value added (current US$) of Egypt, Arab Rep. in 2003 and the Value added (current US$) of Lithuania in 2005?
Ensure brevity in your answer.  2.25e+1. What is the difference between the Value added (current US$) of Brazil in 2004 and the Value added (current US$) of Cuba in 2005?
Provide a succinct answer. 3.41e+11. What is the difference between the Value added (current US$) in Brazil in 2004 and the Value added (current US$) in Egypt, Arab Rep. in 2005?
Ensure brevity in your answer.  3.26e+11. What is the difference between the Value added (current US$) in Brazil in 2004 and the Value added (current US$) in Lithuania in 2005?
Provide a short and direct response. 3.53e+11. What is the difference between the Value added (current US$) in Cuba in 2004 and the Value added (current US$) in Egypt, Arab Rep. in 2005?
Provide a short and direct response. -1.87e+1. What is the difference between the Value added (current US$) of Cuba in 2004 and the Value added (current US$) of Lithuania in 2005?
Offer a terse response. 7.68e+09. What is the difference between the Value added (current US$) of Egypt, Arab Rep. in 2004 and the Value added (current US$) of Lithuania in 2005?
Ensure brevity in your answer.  2.08e+1. What is the average Value added (current US$) of Brazil per year?
Keep it short and to the point. 3.85e+11. What is the average Value added (current US$) of Cuba per year?
Your response must be concise. 1.90e+1. What is the average Value added (current US$) in Egypt, Arab Rep. per year?
Ensure brevity in your answer.  4.12e+1. What is the average Value added (current US$) in Lithuania per year?
Offer a very short reply. 9.03e+09. In the year 1998, what is the difference between the Value added (current US$) of Brazil and Value added (current US$) of Cuba?
Ensure brevity in your answer.  5.18e+11. In the year 1998, what is the difference between the Value added (current US$) in Brazil and Value added (current US$) in Egypt, Arab Rep.?
Your answer should be very brief. 4.91e+11. In the year 1998, what is the difference between the Value added (current US$) of Brazil and Value added (current US$) of Lithuania?
Make the answer very short. 5.26e+11. In the year 1998, what is the difference between the Value added (current US$) in Cuba and Value added (current US$) in Egypt, Arab Rep.?
Offer a very short reply. -2.69e+1. In the year 1998, what is the difference between the Value added (current US$) of Cuba and Value added (current US$) of Lithuania?
Make the answer very short. 8.14e+09. In the year 1998, what is the difference between the Value added (current US$) in Egypt, Arab Rep. and Value added (current US$) in Lithuania?
Provide a succinct answer. 3.50e+1. In the year 1999, what is the difference between the Value added (current US$) of Brazil and Value added (current US$) of Cuba?
Your answer should be very brief. 3.49e+11. In the year 1999, what is the difference between the Value added (current US$) of Brazil and Value added (current US$) of Egypt, Arab Rep.?
Your response must be concise. 3.21e+11. In the year 1999, what is the difference between the Value added (current US$) of Brazil and Value added (current US$) of Lithuania?
Provide a short and direct response. 3.58e+11. In the year 1999, what is the difference between the Value added (current US$) of Cuba and Value added (current US$) of Egypt, Arab Rep.?
Your answer should be compact. -2.76e+1. In the year 1999, what is the difference between the Value added (current US$) in Cuba and Value added (current US$) in Lithuania?
Offer a terse response. 9.51e+09. In the year 1999, what is the difference between the Value added (current US$) in Egypt, Arab Rep. and Value added (current US$) in Lithuania?
Your answer should be compact. 3.71e+1. In the year 2000, what is the difference between the Value added (current US$) of Brazil and Value added (current US$) of Cuba?
Make the answer very short. 3.68e+11. In the year 2000, what is the difference between the Value added (current US$) of Brazil and Value added (current US$) of Egypt, Arab Rep.?
Offer a very short reply. 3.38e+11. In the year 2000, what is the difference between the Value added (current US$) in Brazil and Value added (current US$) in Lithuania?
Offer a terse response. 3.78e+11. In the year 2000, what is the difference between the Value added (current US$) of Cuba and Value added (current US$) of Egypt, Arab Rep.?
Your answer should be very brief. -3.00e+1. In the year 2000, what is the difference between the Value added (current US$) in Cuba and Value added (current US$) in Lithuania?
Provide a short and direct response. 9.83e+09. In the year 2000, what is the difference between the Value added (current US$) of Egypt, Arab Rep. and Value added (current US$) of Lithuania?
Provide a short and direct response. 3.99e+1. In the year 2001, what is the difference between the Value added (current US$) in Brazil and Value added (current US$) in Cuba?
Give a very brief answer. 3.07e+11. In the year 2001, what is the difference between the Value added (current US$) of Brazil and Value added (current US$) of Egypt, Arab Rep.?
Your answer should be compact. 2.79e+11. In the year 2001, what is the difference between the Value added (current US$) of Brazil and Value added (current US$) of Lithuania?
Your response must be concise. 3.17e+11. In the year 2001, what is the difference between the Value added (current US$) of Cuba and Value added (current US$) of Egypt, Arab Rep.?
Keep it short and to the point. -2.78e+1. In the year 2001, what is the difference between the Value added (current US$) of Cuba and Value added (current US$) of Lithuania?
Offer a terse response. 1.06e+1. In the year 2001, what is the difference between the Value added (current US$) in Egypt, Arab Rep. and Value added (current US$) in Lithuania?
Make the answer very short. 3.84e+1. In the year 2002, what is the difference between the Value added (current US$) of Brazil and Value added (current US$) of Cuba?
Ensure brevity in your answer.  2.73e+11. In the year 2002, what is the difference between the Value added (current US$) in Brazil and Value added (current US$) in Egypt, Arab Rep.?
Offer a terse response. 2.52e+11. In the year 2002, what is the difference between the Value added (current US$) in Brazil and Value added (current US$) in Lithuania?
Your response must be concise. 2.84e+11. In the year 2002, what is the difference between the Value added (current US$) of Cuba and Value added (current US$) of Egypt, Arab Rep.?
Provide a succinct answer. -2.11e+1. In the year 2002, what is the difference between the Value added (current US$) in Cuba and Value added (current US$) in Lithuania?
Ensure brevity in your answer.  1.07e+1. In the year 2002, what is the difference between the Value added (current US$) in Egypt, Arab Rep. and Value added (current US$) in Lithuania?
Ensure brevity in your answer.  3.18e+1. In the year 2003, what is the difference between the Value added (current US$) in Brazil and Value added (current US$) in Cuba?
Provide a succinct answer. 2.94e+11. In the year 2003, what is the difference between the Value added (current US$) of Brazil and Value added (current US$) of Egypt, Arab Rep.?
Provide a succinct answer. 2.78e+11. In the year 2003, what is the difference between the Value added (current US$) of Brazil and Value added (current US$) of Lithuania?
Ensure brevity in your answer.  3.04e+11. In the year 2003, what is the difference between the Value added (current US$) of Cuba and Value added (current US$) of Egypt, Arab Rep.?
Give a very brief answer. -1.66e+1. In the year 2003, what is the difference between the Value added (current US$) in Cuba and Value added (current US$) in Lithuania?
Your answer should be very brief. 9.89e+09. In the year 2003, what is the difference between the Value added (current US$) of Egypt, Arab Rep. and Value added (current US$) of Lithuania?
Your answer should be very brief. 2.64e+1. In the year 2004, what is the difference between the Value added (current US$) of Brazil and Value added (current US$) of Cuba?
Make the answer very short. 3.45e+11. In the year 2004, what is the difference between the Value added (current US$) of Brazil and Value added (current US$) of Egypt, Arab Rep.?
Provide a short and direct response. 3.32e+11. In the year 2004, what is the difference between the Value added (current US$) of Brazil and Value added (current US$) of Lithuania?
Your answer should be compact. 3.54e+11. In the year 2004, what is the difference between the Value added (current US$) in Cuba and Value added (current US$) in Egypt, Arab Rep.?
Your answer should be very brief. -1.31e+1. In the year 2004, what is the difference between the Value added (current US$) of Cuba and Value added (current US$) of Lithuania?
Your answer should be very brief. 9.61e+09. In the year 2004, what is the difference between the Value added (current US$) in Egypt, Arab Rep. and Value added (current US$) in Lithuania?
Your answer should be compact. 2.27e+1. In the year 2005, what is the difference between the Value added (current US$) in Brazil and Value added (current US$) in Cuba?
Your response must be concise. 4.73e+11. In the year 2005, what is the difference between the Value added (current US$) in Brazil and Value added (current US$) in Egypt, Arab Rep.?
Give a very brief answer. 4.58e+11. In the year 2005, what is the difference between the Value added (current US$) in Brazil and Value added (current US$) in Lithuania?
Make the answer very short. 4.84e+11. In the year 2005, what is the difference between the Value added (current US$) of Cuba and Value added (current US$) of Egypt, Arab Rep.?
Give a very brief answer. -1.50e+1. In the year 2005, what is the difference between the Value added (current US$) of Cuba and Value added (current US$) of Lithuania?
Ensure brevity in your answer.  1.14e+1. In the year 2005, what is the difference between the Value added (current US$) in Egypt, Arab Rep. and Value added (current US$) in Lithuania?
Make the answer very short. 2.64e+1. What is the ratio of the Value added (current US$) of Brazil in 1998 to that in 1999?
Provide a short and direct response. 1.46. What is the ratio of the Value added (current US$) in Cuba in 1998 to that in 1999?
Your answer should be very brief. 0.9. What is the ratio of the Value added (current US$) of Egypt, Arab Rep. in 1998 to that in 1999?
Your response must be concise. 0.95. What is the ratio of the Value added (current US$) in Lithuania in 1998 to that in 1999?
Give a very brief answer. 0.98. What is the ratio of the Value added (current US$) of Brazil in 1998 to that in 2000?
Your answer should be very brief. 1.38. What is the ratio of the Value added (current US$) in Cuba in 1998 to that in 2000?
Offer a terse response. 0.86. What is the ratio of the Value added (current US$) in Egypt, Arab Rep. in 1998 to that in 2000?
Give a very brief answer. 0.88. What is the ratio of the Value added (current US$) of Lithuania in 1998 to that in 2000?
Your answer should be very brief. 0.9. What is the ratio of the Value added (current US$) of Brazil in 1998 to that in 2001?
Your answer should be compact. 1.64. What is the ratio of the Value added (current US$) of Cuba in 1998 to that in 2001?
Offer a very short reply. 0.8. What is the ratio of the Value added (current US$) in Egypt, Arab Rep. in 1998 to that in 2001?
Make the answer very short. 0.9. What is the ratio of the Value added (current US$) of Lithuania in 1998 to that in 2001?
Your answer should be very brief. 0.85. What is the ratio of the Value added (current US$) of Brazil in 1998 to that in 2002?
Your response must be concise. 1.82. What is the ratio of the Value added (current US$) of Cuba in 1998 to that in 2002?
Provide a succinct answer. 0.74. What is the ratio of the Value added (current US$) of Egypt, Arab Rep. in 1998 to that in 2002?
Your answer should be compact. 1.02. What is the ratio of the Value added (current US$) of Lithuania in 1998 to that in 2002?
Provide a short and direct response. 0.72. What is the ratio of the Value added (current US$) in Brazil in 1998 to that in 2003?
Your answer should be very brief. 1.69. What is the ratio of the Value added (current US$) in Cuba in 1998 to that in 2003?
Keep it short and to the point. 0.68. What is the ratio of the Value added (current US$) in Lithuania in 1998 to that in 2003?
Your answer should be very brief. 0.55. What is the ratio of the Value added (current US$) of Brazil in 1998 to that in 2004?
Provide a succinct answer. 1.45. What is the ratio of the Value added (current US$) of Cuba in 1998 to that in 2004?
Ensure brevity in your answer.  0.63. What is the ratio of the Value added (current US$) in Egypt, Arab Rep. in 1998 to that in 2004?
Keep it short and to the point. 1.15. What is the ratio of the Value added (current US$) of Lithuania in 1998 to that in 2004?
Your response must be concise. 0.46. What is the ratio of the Value added (current US$) of Brazil in 1998 to that in 2005?
Your response must be concise. 1.07. What is the ratio of the Value added (current US$) of Cuba in 1998 to that in 2005?
Provide a succinct answer. 0.54. What is the ratio of the Value added (current US$) of Egypt, Arab Rep. in 1998 to that in 2005?
Your answer should be compact. 1. What is the ratio of the Value added (current US$) of Lithuania in 1998 to that in 2005?
Ensure brevity in your answer.  0.4. What is the ratio of the Value added (current US$) in Brazil in 1999 to that in 2000?
Offer a terse response. 0.95. What is the ratio of the Value added (current US$) in Cuba in 1999 to that in 2000?
Your answer should be very brief. 0.95. What is the ratio of the Value added (current US$) in Egypt, Arab Rep. in 1999 to that in 2000?
Ensure brevity in your answer.  0.93. What is the ratio of the Value added (current US$) in Lithuania in 1999 to that in 2000?
Offer a terse response. 0.92. What is the ratio of the Value added (current US$) of Brazil in 1999 to that in 2001?
Your answer should be very brief. 1.12. What is the ratio of the Value added (current US$) in Cuba in 1999 to that in 2001?
Offer a very short reply. 0.89. What is the ratio of the Value added (current US$) of Egypt, Arab Rep. in 1999 to that in 2001?
Your answer should be compact. 0.95. What is the ratio of the Value added (current US$) of Lithuania in 1999 to that in 2001?
Keep it short and to the point. 0.87. What is the ratio of the Value added (current US$) in Brazil in 1999 to that in 2002?
Your answer should be compact. 1.25. What is the ratio of the Value added (current US$) of Cuba in 1999 to that in 2002?
Offer a terse response. 0.82. What is the ratio of the Value added (current US$) in Egypt, Arab Rep. in 1999 to that in 2002?
Keep it short and to the point. 1.08. What is the ratio of the Value added (current US$) of Lithuania in 1999 to that in 2002?
Ensure brevity in your answer.  0.73. What is the ratio of the Value added (current US$) in Brazil in 1999 to that in 2003?
Offer a terse response. 1.16. What is the ratio of the Value added (current US$) of Cuba in 1999 to that in 2003?
Ensure brevity in your answer.  0.75. What is the ratio of the Value added (current US$) in Egypt, Arab Rep. in 1999 to that in 2003?
Your answer should be very brief. 1.16. What is the ratio of the Value added (current US$) of Lithuania in 1999 to that in 2003?
Your answer should be very brief. 0.56. What is the ratio of the Value added (current US$) in Cuba in 1999 to that in 2004?
Keep it short and to the point. 0.69. What is the ratio of the Value added (current US$) in Egypt, Arab Rep. in 1999 to that in 2004?
Your answer should be very brief. 1.21. What is the ratio of the Value added (current US$) in Lithuania in 1999 to that in 2004?
Keep it short and to the point. 0.47. What is the ratio of the Value added (current US$) of Brazil in 1999 to that in 2005?
Make the answer very short. 0.73. What is the ratio of the Value added (current US$) in Cuba in 1999 to that in 2005?
Offer a terse response. 0.59. What is the ratio of the Value added (current US$) in Egypt, Arab Rep. in 1999 to that in 2005?
Ensure brevity in your answer.  1.05. What is the ratio of the Value added (current US$) in Lithuania in 1999 to that in 2005?
Your answer should be very brief. 0.41. What is the ratio of the Value added (current US$) of Brazil in 2000 to that in 2001?
Provide a succinct answer. 1.19. What is the ratio of the Value added (current US$) of Egypt, Arab Rep. in 2000 to that in 2001?
Ensure brevity in your answer.  1.02. What is the ratio of the Value added (current US$) in Brazil in 2000 to that in 2002?
Offer a very short reply. 1.32. What is the ratio of the Value added (current US$) in Cuba in 2000 to that in 2002?
Provide a short and direct response. 0.87. What is the ratio of the Value added (current US$) in Egypt, Arab Rep. in 2000 to that in 2002?
Keep it short and to the point. 1.16. What is the ratio of the Value added (current US$) in Lithuania in 2000 to that in 2002?
Offer a very short reply. 0.79. What is the ratio of the Value added (current US$) in Brazil in 2000 to that in 2003?
Your answer should be very brief. 1.22. What is the ratio of the Value added (current US$) of Cuba in 2000 to that in 2003?
Give a very brief answer. 0.79. What is the ratio of the Value added (current US$) in Egypt, Arab Rep. in 2000 to that in 2003?
Make the answer very short. 1.25. What is the ratio of the Value added (current US$) of Lithuania in 2000 to that in 2003?
Provide a succinct answer. 0.61. What is the ratio of the Value added (current US$) of Brazil in 2000 to that in 2004?
Keep it short and to the point. 1.05. What is the ratio of the Value added (current US$) of Cuba in 2000 to that in 2004?
Give a very brief answer. 0.73. What is the ratio of the Value added (current US$) in Egypt, Arab Rep. in 2000 to that in 2004?
Your response must be concise. 1.31. What is the ratio of the Value added (current US$) in Lithuania in 2000 to that in 2004?
Offer a terse response. 0.51. What is the ratio of the Value added (current US$) in Brazil in 2000 to that in 2005?
Give a very brief answer. 0.77. What is the ratio of the Value added (current US$) of Cuba in 2000 to that in 2005?
Your response must be concise. 0.63. What is the ratio of the Value added (current US$) in Egypt, Arab Rep. in 2000 to that in 2005?
Give a very brief answer. 1.13. What is the ratio of the Value added (current US$) of Lithuania in 2000 to that in 2005?
Provide a short and direct response. 0.44. What is the ratio of the Value added (current US$) in Brazil in 2001 to that in 2002?
Offer a terse response. 1.11. What is the ratio of the Value added (current US$) of Cuba in 2001 to that in 2002?
Provide a succinct answer. 0.93. What is the ratio of the Value added (current US$) in Egypt, Arab Rep. in 2001 to that in 2002?
Offer a terse response. 1.13. What is the ratio of the Value added (current US$) of Lithuania in 2001 to that in 2002?
Provide a short and direct response. 0.85. What is the ratio of the Value added (current US$) in Brazil in 2001 to that in 2003?
Make the answer very short. 1.03. What is the ratio of the Value added (current US$) in Cuba in 2001 to that in 2003?
Your answer should be compact. 0.85. What is the ratio of the Value added (current US$) in Egypt, Arab Rep. in 2001 to that in 2003?
Your answer should be very brief. 1.22. What is the ratio of the Value added (current US$) in Lithuania in 2001 to that in 2003?
Your response must be concise. 0.65. What is the ratio of the Value added (current US$) of Brazil in 2001 to that in 2004?
Offer a very short reply. 0.88. What is the ratio of the Value added (current US$) of Cuba in 2001 to that in 2004?
Provide a succinct answer. 0.78. What is the ratio of the Value added (current US$) in Egypt, Arab Rep. in 2001 to that in 2004?
Your answer should be compact. 1.28. What is the ratio of the Value added (current US$) of Lithuania in 2001 to that in 2004?
Your answer should be very brief. 0.54. What is the ratio of the Value added (current US$) of Brazil in 2001 to that in 2005?
Keep it short and to the point. 0.65. What is the ratio of the Value added (current US$) in Cuba in 2001 to that in 2005?
Keep it short and to the point. 0.67. What is the ratio of the Value added (current US$) of Egypt, Arab Rep. in 2001 to that in 2005?
Give a very brief answer. 1.1. What is the ratio of the Value added (current US$) of Lithuania in 2001 to that in 2005?
Offer a terse response. 0.47. What is the ratio of the Value added (current US$) of Brazil in 2002 to that in 2003?
Provide a short and direct response. 0.93. What is the ratio of the Value added (current US$) of Cuba in 2002 to that in 2003?
Provide a succinct answer. 0.92. What is the ratio of the Value added (current US$) in Egypt, Arab Rep. in 2002 to that in 2003?
Ensure brevity in your answer.  1.08. What is the ratio of the Value added (current US$) in Lithuania in 2002 to that in 2003?
Keep it short and to the point. 0.77. What is the ratio of the Value added (current US$) of Brazil in 2002 to that in 2004?
Offer a terse response. 0.8. What is the ratio of the Value added (current US$) of Cuba in 2002 to that in 2004?
Provide a short and direct response. 0.84. What is the ratio of the Value added (current US$) of Egypt, Arab Rep. in 2002 to that in 2004?
Ensure brevity in your answer.  1.13. What is the ratio of the Value added (current US$) in Lithuania in 2002 to that in 2004?
Make the answer very short. 0.64. What is the ratio of the Value added (current US$) in Brazil in 2002 to that in 2005?
Keep it short and to the point. 0.59. What is the ratio of the Value added (current US$) in Cuba in 2002 to that in 2005?
Keep it short and to the point. 0.72. What is the ratio of the Value added (current US$) of Egypt, Arab Rep. in 2002 to that in 2005?
Your response must be concise. 0.97. What is the ratio of the Value added (current US$) in Lithuania in 2002 to that in 2005?
Your answer should be very brief. 0.56. What is the ratio of the Value added (current US$) in Brazil in 2003 to that in 2004?
Offer a very short reply. 0.86. What is the ratio of the Value added (current US$) in Cuba in 2003 to that in 2004?
Provide a succinct answer. 0.92. What is the ratio of the Value added (current US$) in Egypt, Arab Rep. in 2003 to that in 2004?
Your answer should be very brief. 1.05. What is the ratio of the Value added (current US$) in Lithuania in 2003 to that in 2004?
Give a very brief answer. 0.84. What is the ratio of the Value added (current US$) in Brazil in 2003 to that in 2005?
Offer a terse response. 0.63. What is the ratio of the Value added (current US$) of Cuba in 2003 to that in 2005?
Ensure brevity in your answer.  0.79. What is the ratio of the Value added (current US$) in Egypt, Arab Rep. in 2003 to that in 2005?
Keep it short and to the point. 0.91. What is the ratio of the Value added (current US$) in Lithuania in 2003 to that in 2005?
Ensure brevity in your answer.  0.73. What is the ratio of the Value added (current US$) in Brazil in 2004 to that in 2005?
Offer a very short reply. 0.74. What is the ratio of the Value added (current US$) of Cuba in 2004 to that in 2005?
Ensure brevity in your answer.  0.86. What is the ratio of the Value added (current US$) in Egypt, Arab Rep. in 2004 to that in 2005?
Your answer should be compact. 0.86. What is the ratio of the Value added (current US$) of Lithuania in 2004 to that in 2005?
Provide a short and direct response. 0.87. What is the difference between the highest and the second highest Value added (current US$) of Brazil?
Make the answer very short. 3.30e+1. What is the difference between the highest and the second highest Value added (current US$) of Cuba?
Ensure brevity in your answer.  3.72e+09. What is the difference between the highest and the second highest Value added (current US$) in Egypt, Arab Rep.?
Your answer should be compact. 1.09e+09. What is the difference between the highest and the second highest Value added (current US$) of Lithuania?
Offer a very short reply. 1.93e+09. What is the difference between the highest and the lowest Value added (current US$) of Brazil?
Your response must be concise. 2.40e+11. What is the difference between the highest and the lowest Value added (current US$) of Cuba?
Provide a succinct answer. 1.21e+1. What is the difference between the highest and the lowest Value added (current US$) of Egypt, Arab Rep.?
Provide a short and direct response. 1.09e+1. What is the difference between the highest and the lowest Value added (current US$) in Lithuania?
Your answer should be very brief. 8.86e+09. 